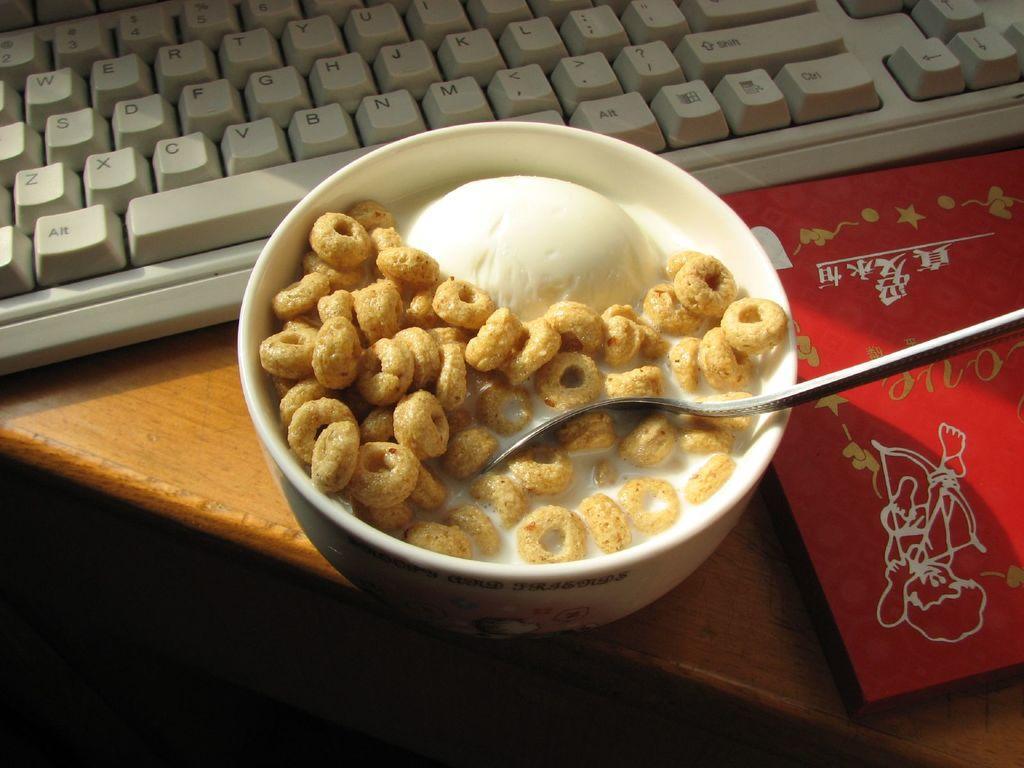Can you describe this image briefly? In this image we can see a bowl with food item, red color book and a keyboard are kept on the wooden table. 